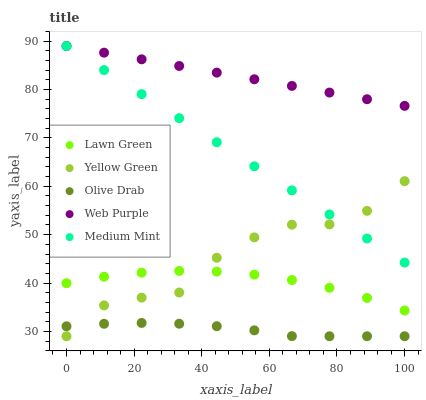Does Olive Drab have the minimum area under the curve?
Answer yes or no. Yes. Does Web Purple have the maximum area under the curve?
Answer yes or no. Yes. Does Lawn Green have the minimum area under the curve?
Answer yes or no. No. Does Lawn Green have the maximum area under the curve?
Answer yes or no. No. Is Web Purple the smoothest?
Answer yes or no. Yes. Is Yellow Green the roughest?
Answer yes or no. Yes. Is Lawn Green the smoothest?
Answer yes or no. No. Is Lawn Green the roughest?
Answer yes or no. No. Does Yellow Green have the lowest value?
Answer yes or no. Yes. Does Lawn Green have the lowest value?
Answer yes or no. No. Does Web Purple have the highest value?
Answer yes or no. Yes. Does Lawn Green have the highest value?
Answer yes or no. No. Is Olive Drab less than Medium Mint?
Answer yes or no. Yes. Is Medium Mint greater than Olive Drab?
Answer yes or no. Yes. Does Lawn Green intersect Yellow Green?
Answer yes or no. Yes. Is Lawn Green less than Yellow Green?
Answer yes or no. No. Is Lawn Green greater than Yellow Green?
Answer yes or no. No. Does Olive Drab intersect Medium Mint?
Answer yes or no. No. 